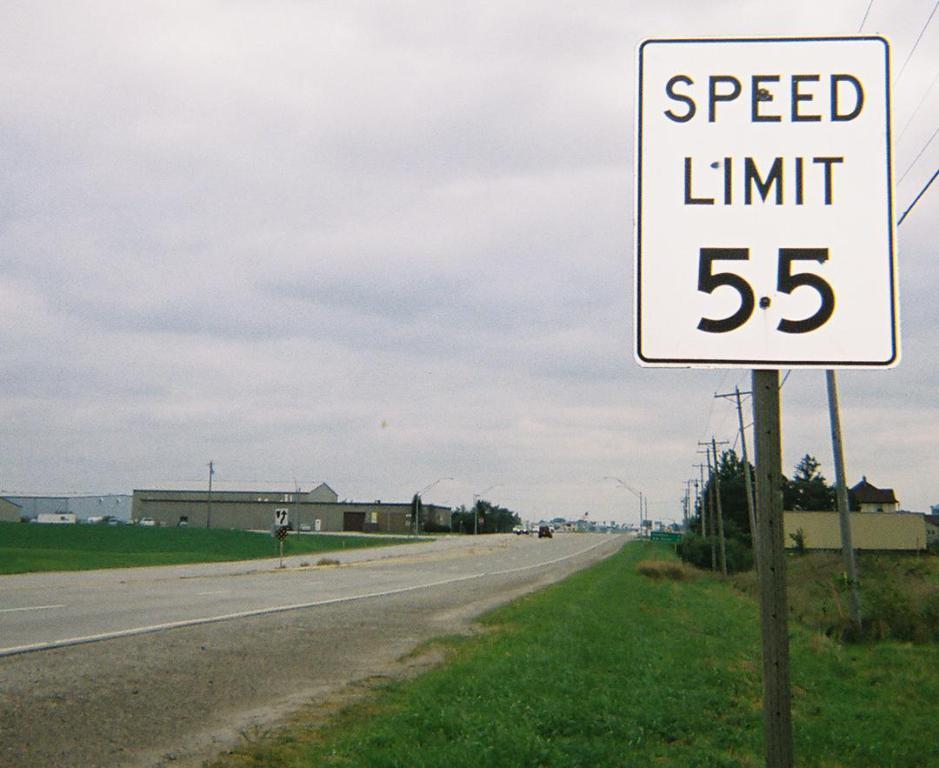How fast is the speed limit on this road?
Provide a succinct answer. 55. What is being limited to 55?
Your answer should be very brief. Speed. 